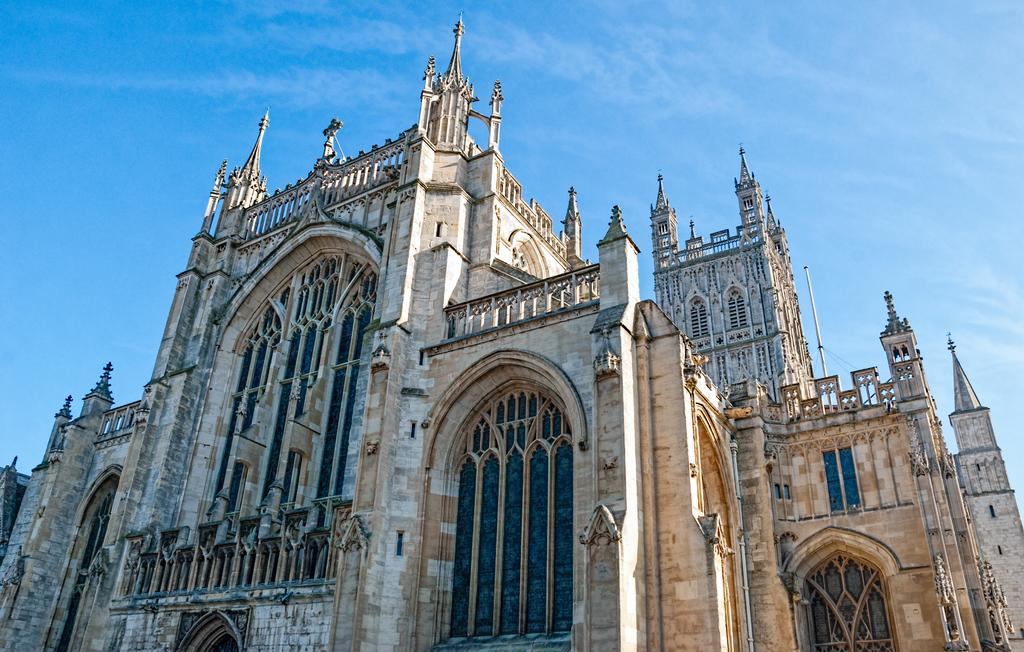What type of structure is visible in the image? There is a building in the image. What feature can be seen on the building? The building has windows. What color is the sky in the image? The sky is blue in color. How many buns are hanging from the building in the image? There are no buns present in the image; it features a building with windows and a blue sky. What type of icicle can be seen on the windows of the building? There are no icicles present on the windows of the building in the image. 